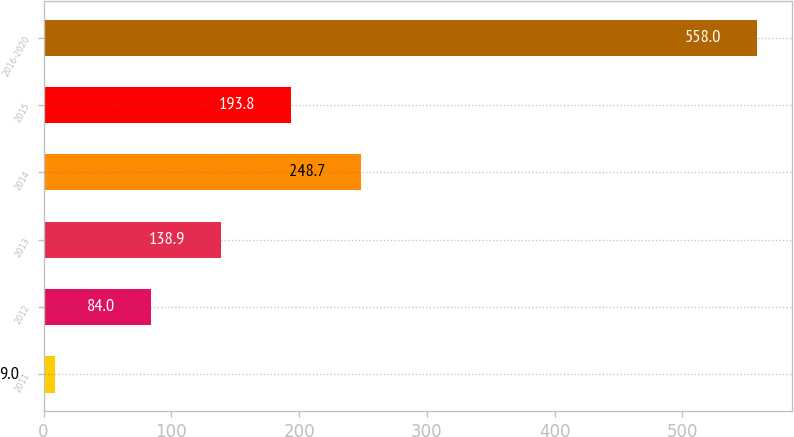Convert chart. <chart><loc_0><loc_0><loc_500><loc_500><bar_chart><fcel>2011<fcel>2012<fcel>2013<fcel>2014<fcel>2015<fcel>2016-2020<nl><fcel>9<fcel>84<fcel>138.9<fcel>248.7<fcel>193.8<fcel>558<nl></chart> 